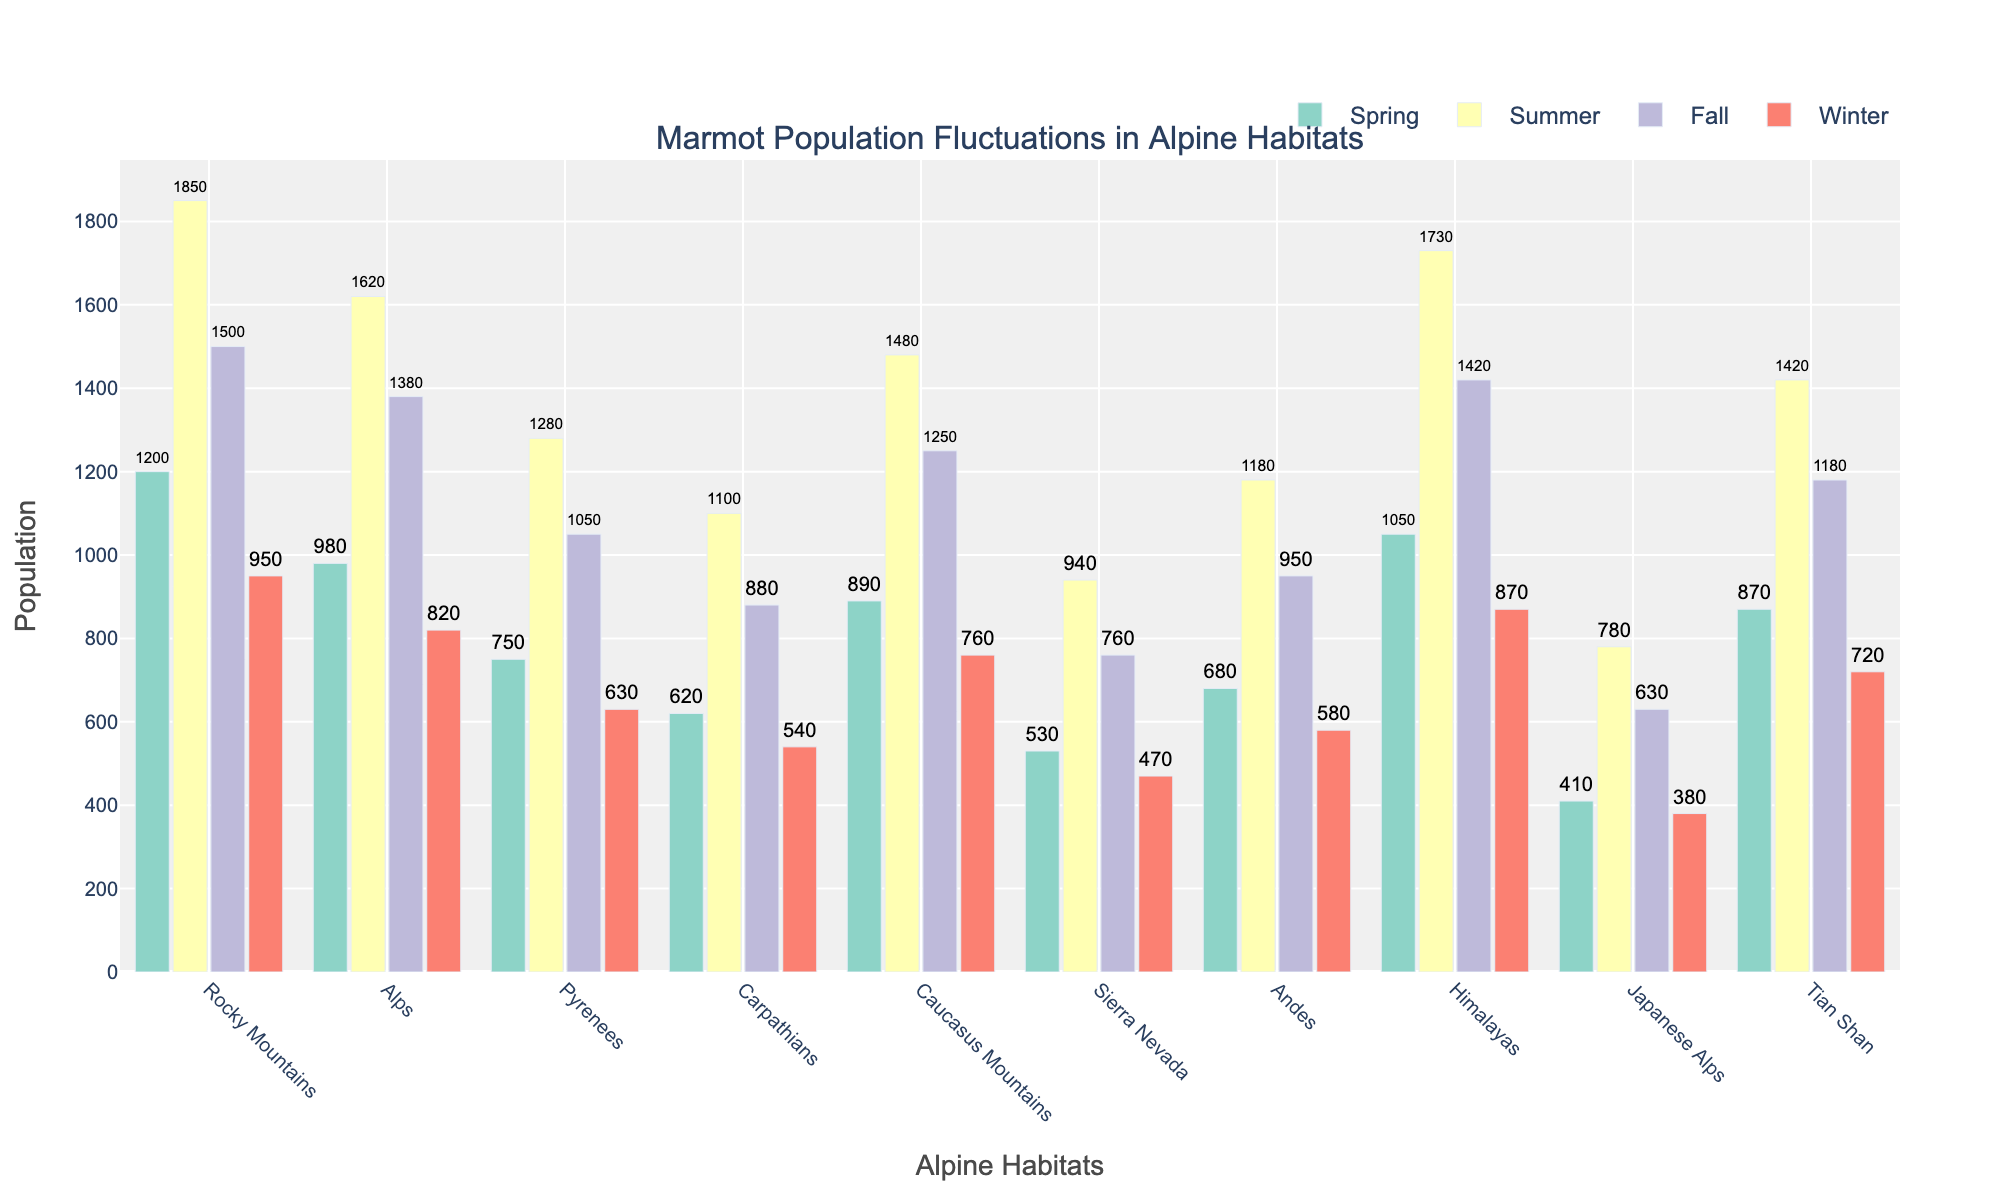What is the highest population of marmots recorded in all habitats during the summer? To find the highest summer population, look at the summer population bars for all habitats and identify the maximum value. The highest population recorded is in the Rocky Mountains with 1850 marmots.
Answer: 1850 Which habitat has the smallest population difference between spring and fall? Calculate the difference between the spring and fall populations for each habitat. The smallest difference is between the spring (870) and fall (880) populations in the Tian Shan, with a difference of 10.
Answer: Tian Shan How many habitats have a higher winter population than the Japanese Alps? Compare the winter populations of all habitats with the winter population of the Japanese Alps (380). The habitats with higher winter populations are: Rocky Mountains, Alps, Pyrenees, Carpathians, Caucasus Mountains, Sierra Nevada, Andes, Himalayas, and Tian Shan, totaling 9.
Answer: 9 What is the average fall population of marmots across all habitats? Sum the fall populations of all habitats (1500 + 1380 + 1050 + 880 + 1250 + 760 + 950 + 1420 + 630 + 1180) which equals 11000, then divide by the number of habitats (10).
Answer: 1100 Which season has the most significant fluctuation in marmot populations across all habitats, and what is this fluctuation? Calculate the range of populations (difference between highest and lowest populations) for each season across all habitats. The winter season has the most significant fluctuation with the highest population (Rocky Mountains, 950) and the lowest (Japanese Alps, 380), resulting in a fluctuation of 950 - 380 = 570.
Answer: Winter, 570 Which habitat shows the least variation in marmot populations across all seasons? Calculate the range of populations for each habitat across all seasons. The habitat with the least variation is the Japanese Alps, with a range of 410 (spring) - 380 (winter) = 30.
Answer: Japanese Alps In which season do the Andes have their maximum population, and how does this compare to their spring population? Identify the Andes' maximum season population (summer, 1180) and compare it to their spring population (680). The summer population is 500 marmots higher than in the spring.
Answer: Summer, 500 Which habitat has the highest fall population, and how does it compare to the fall population in the Himalayas? Identify the habitats with the highest fall population (Rocky Mountains, 1500) and compare it to the fall population in the Himalayas (1420). The Rocky Mountains have 80 more marmots than the Himalayas in the fall.
Answer: Rocky Mountains, 80 